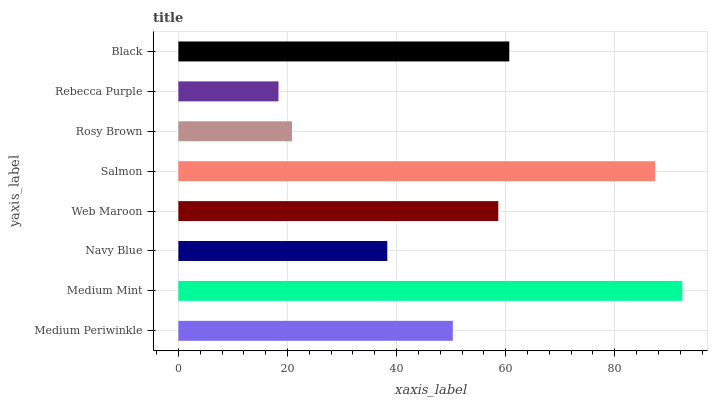Is Rebecca Purple the minimum?
Answer yes or no. Yes. Is Medium Mint the maximum?
Answer yes or no. Yes. Is Navy Blue the minimum?
Answer yes or no. No. Is Navy Blue the maximum?
Answer yes or no. No. Is Medium Mint greater than Navy Blue?
Answer yes or no. Yes. Is Navy Blue less than Medium Mint?
Answer yes or no. Yes. Is Navy Blue greater than Medium Mint?
Answer yes or no. No. Is Medium Mint less than Navy Blue?
Answer yes or no. No. Is Web Maroon the high median?
Answer yes or no. Yes. Is Medium Periwinkle the low median?
Answer yes or no. Yes. Is Medium Mint the high median?
Answer yes or no. No. Is Navy Blue the low median?
Answer yes or no. No. 